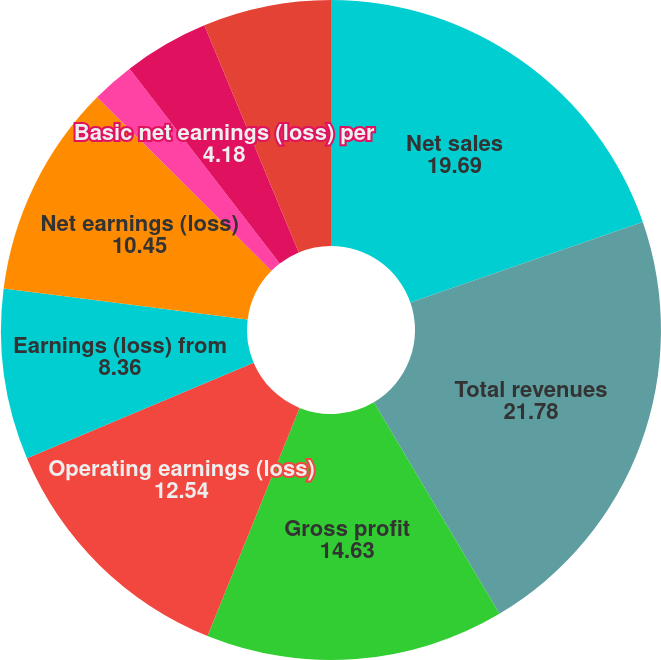<chart> <loc_0><loc_0><loc_500><loc_500><pie_chart><fcel>Net sales<fcel>Total revenues<fcel>Gross profit<fcel>Operating earnings (loss)<fcel>Earnings (loss) from<fcel>Net earnings (loss)<fcel>Basic earnings (loss) per<fcel>Diluted earnings (loss) per<fcel>Basic net earnings (loss) per<fcel>Diluted net earnings (loss)<nl><fcel>19.69%<fcel>21.78%<fcel>14.63%<fcel>12.54%<fcel>8.36%<fcel>10.45%<fcel>0.0%<fcel>2.09%<fcel>4.18%<fcel>6.27%<nl></chart> 